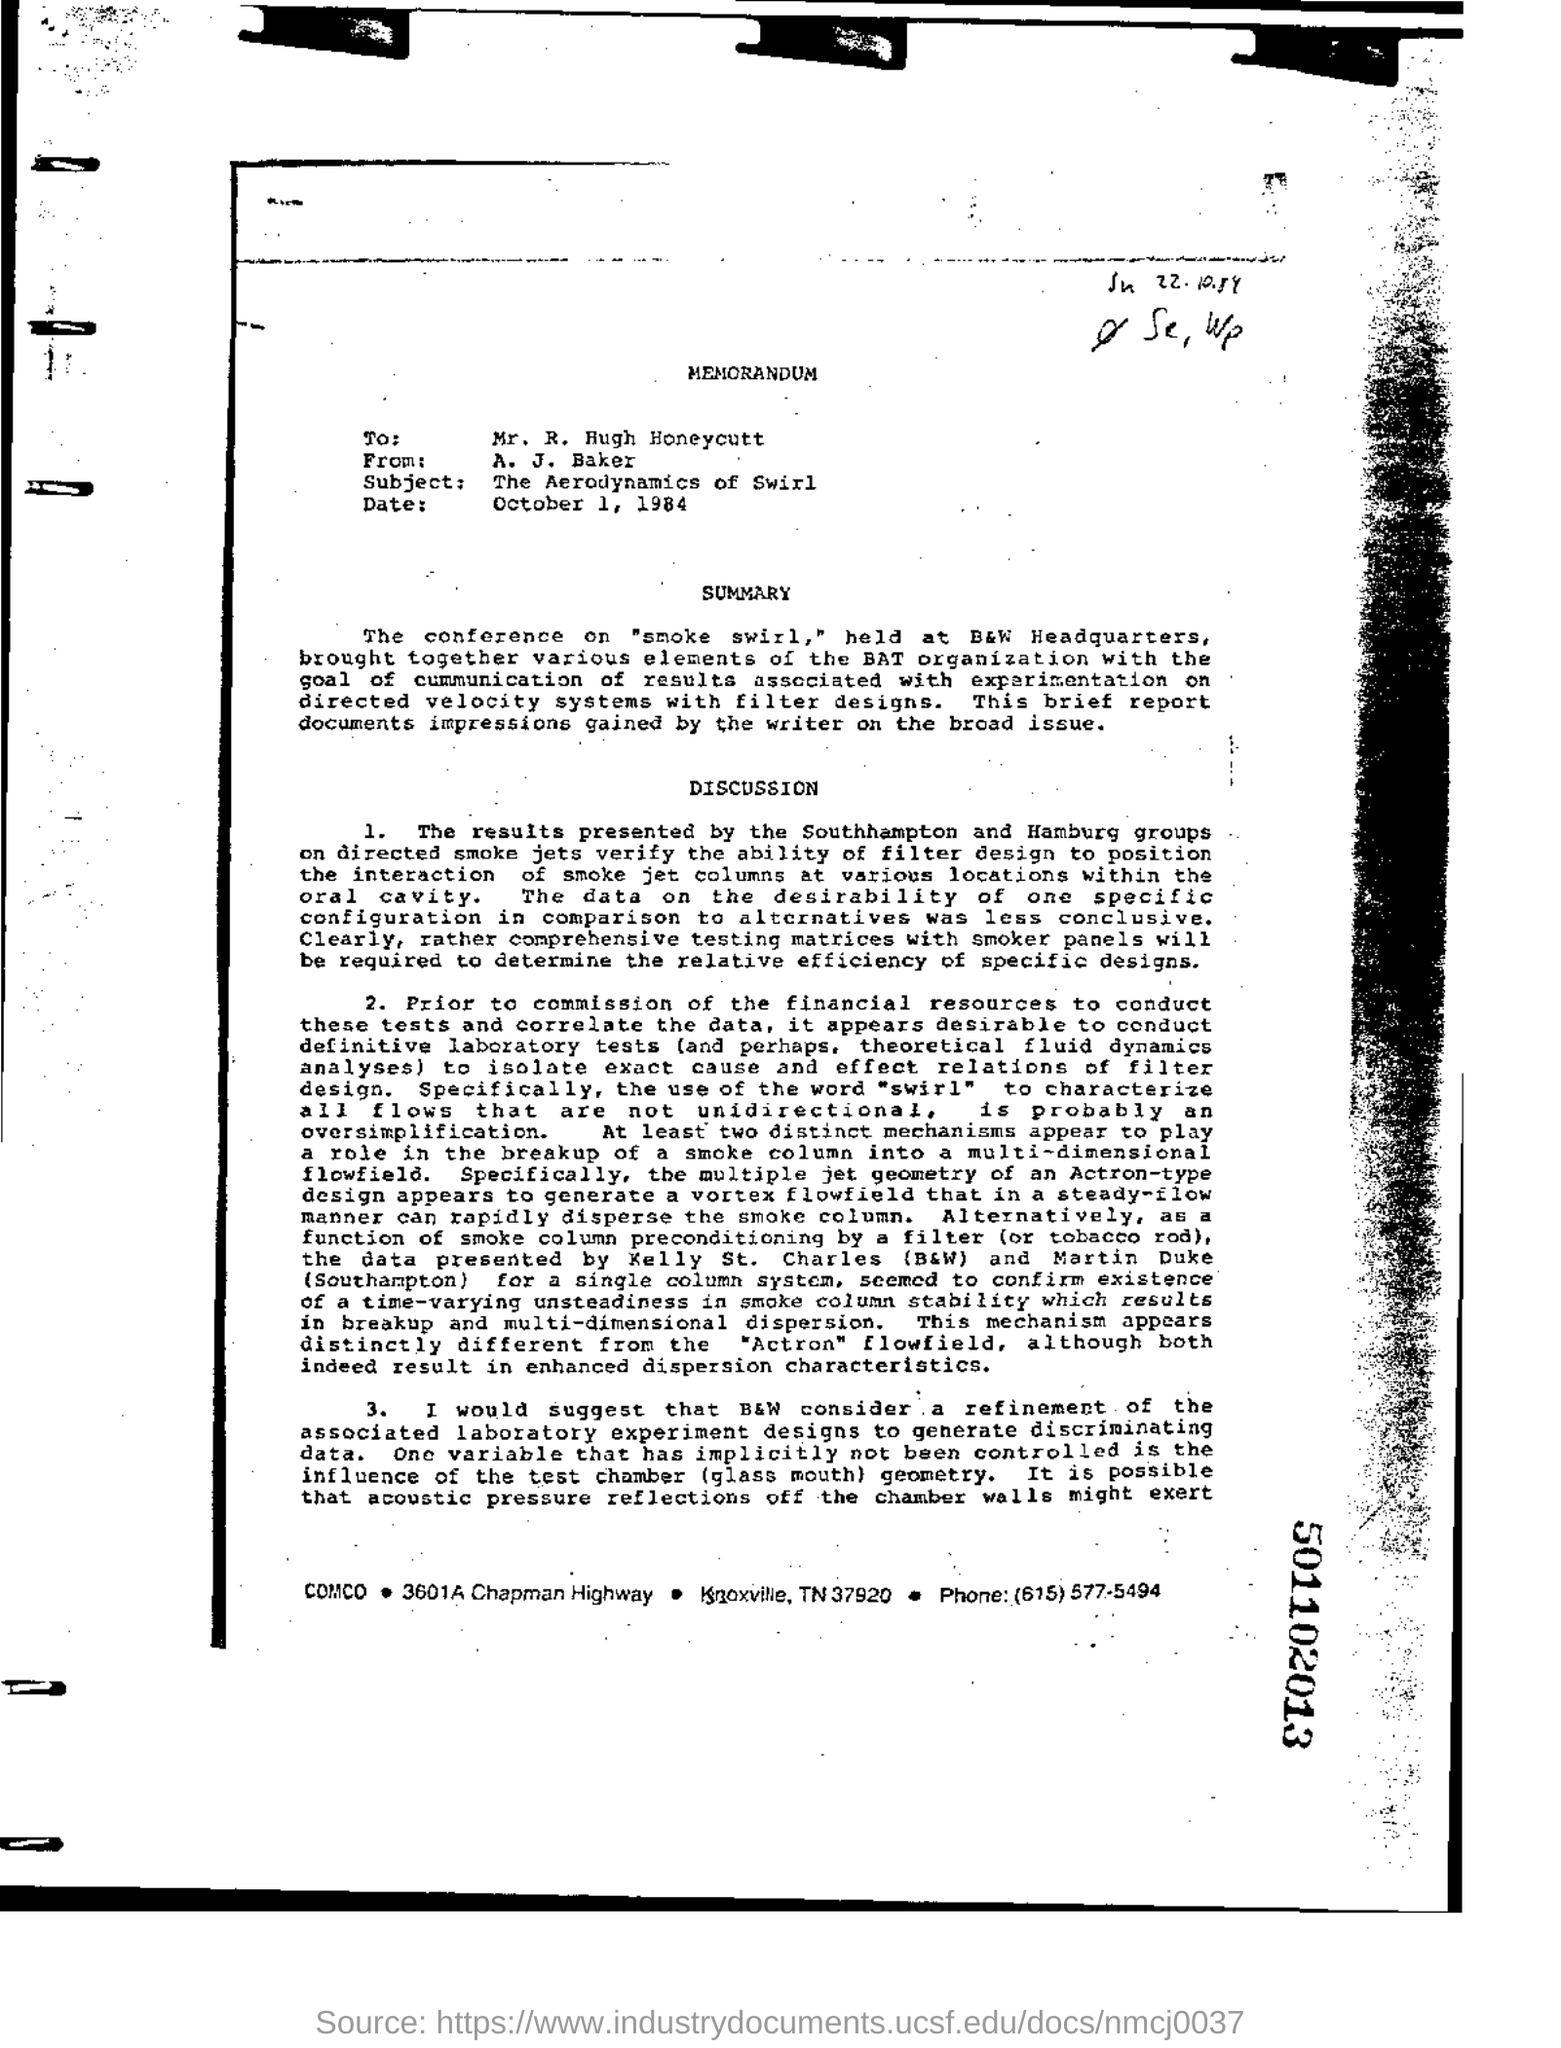Give some essential details in this illustration. At least two distinct mechanisms appear to play a role in the breakup of a smoke column into a multi-dimensional flowfield. Is this document a memorandum? The conference was held at B&W headquarters. The test chamber's glass mouth geometry has an uncontrolled influence on the variable being tested. 